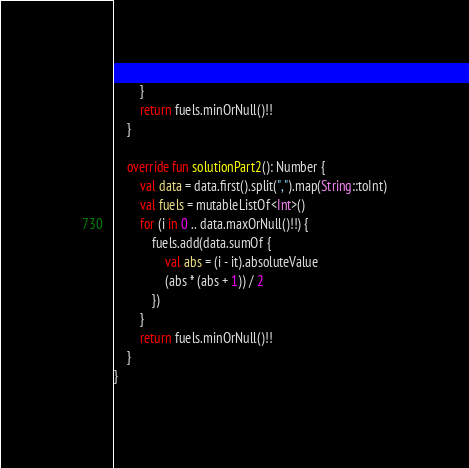Convert code to text. <code><loc_0><loc_0><loc_500><loc_500><_Kotlin_>        }
        return fuels.minOrNull()!!
    }

    override fun solutionPart2(): Number {
        val data = data.first().split(",").map(String::toInt)
        val fuels = mutableListOf<Int>()
        for (i in 0 .. data.maxOrNull()!!) {
            fuels.add(data.sumOf {
                val abs = (i - it).absoluteValue
                (abs * (abs + 1)) / 2
            })
        }
        return fuels.minOrNull()!!
    }
}</code> 